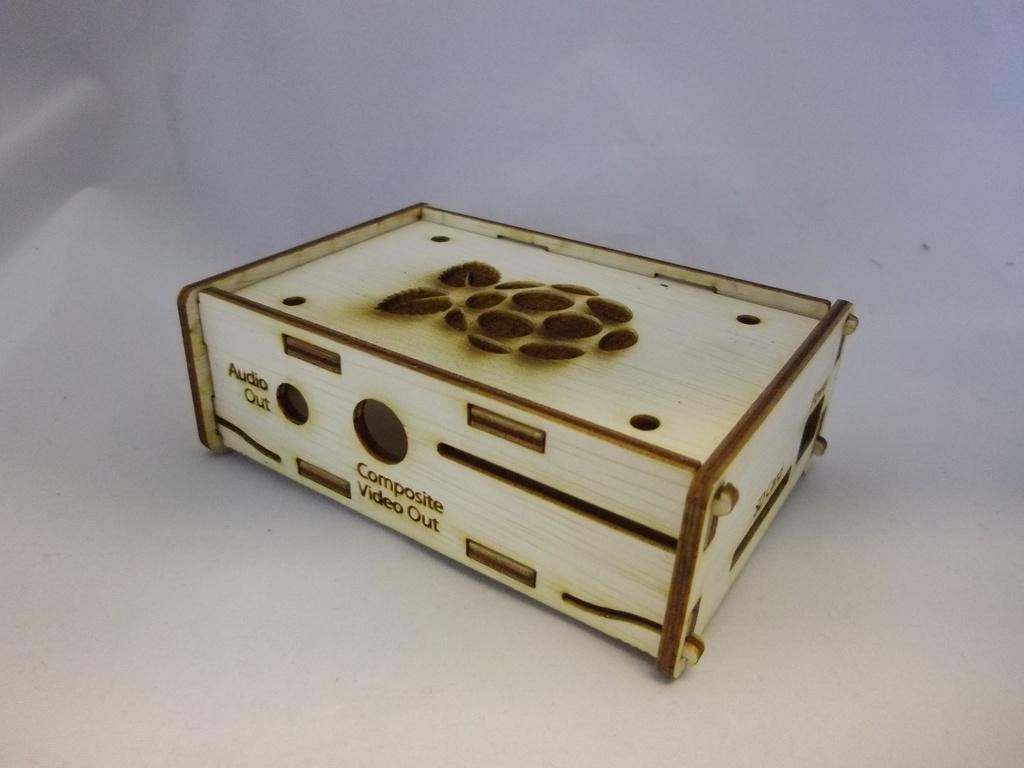Provide a one-sentence caption for the provided image. A case for a raspberry pi micro computer that has holes cutout for Audio Out. 